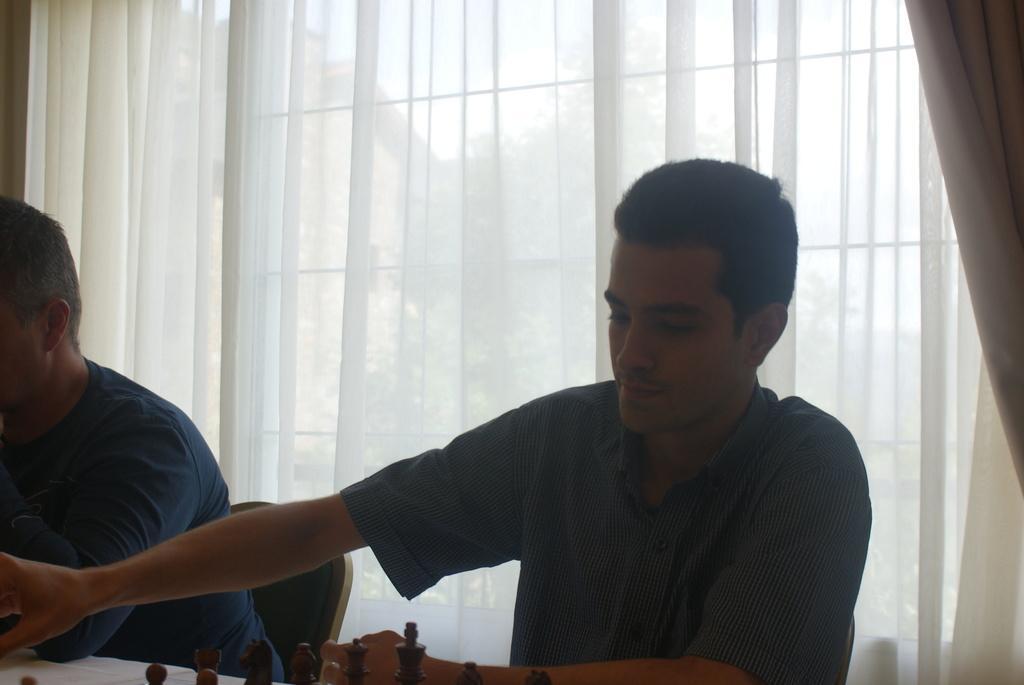In one or two sentences, can you explain what this image depicts? In the foreground we can see people, chair, white color object and chess coins. In the background there are curtains and window. In the background we can see trees, building and sky. 